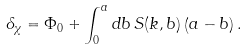<formula> <loc_0><loc_0><loc_500><loc_500>\delta _ { \chi } = \Phi _ { 0 } + \int _ { 0 } ^ { a } d b \, S ( k , b ) \left ( a - b \right ) .</formula> 